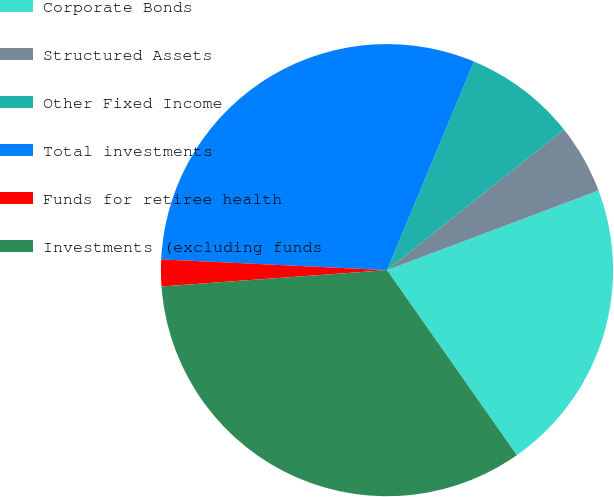Convert chart to OTSL. <chart><loc_0><loc_0><loc_500><loc_500><pie_chart><fcel>Corporate Bonds<fcel>Structured Assets<fcel>Other Fixed Income<fcel>Total investments<fcel>Funds for retiree health<fcel>Investments (excluding funds<nl><fcel>20.99%<fcel>4.96%<fcel>8.02%<fcel>30.53%<fcel>1.91%<fcel>33.59%<nl></chart> 